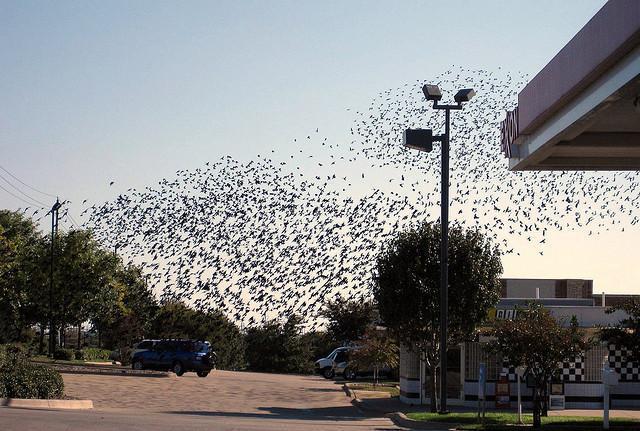How many newspaper vending machines are there?
Give a very brief answer. 2. 